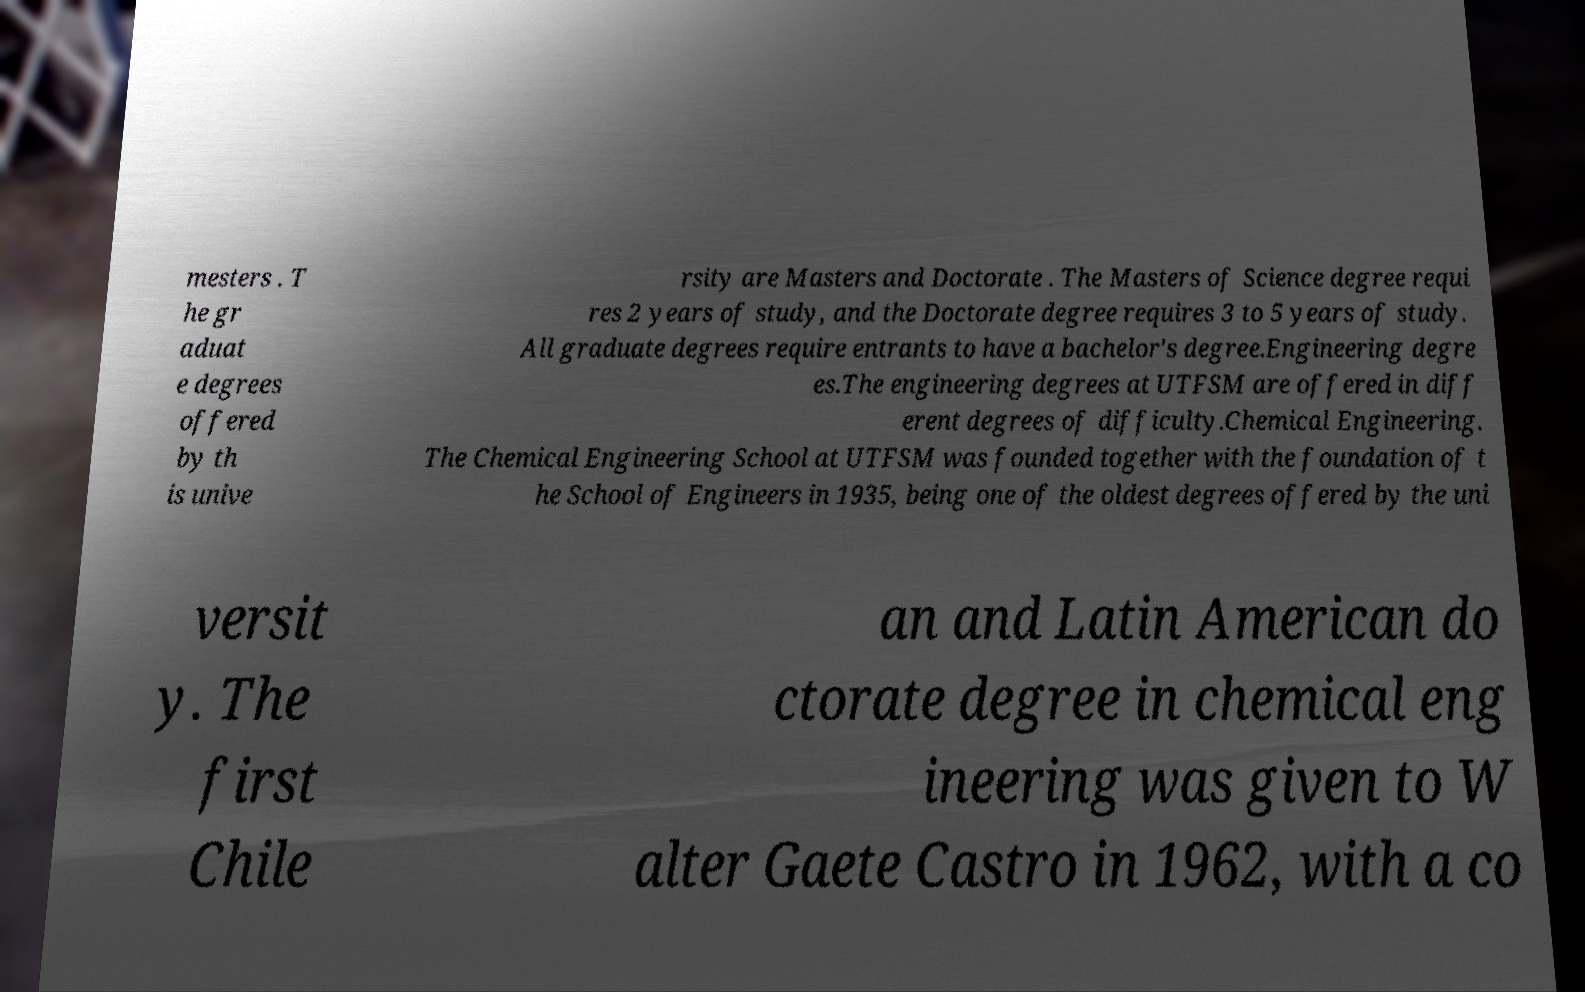Could you extract and type out the text from this image? mesters . T he gr aduat e degrees offered by th is unive rsity are Masters and Doctorate . The Masters of Science degree requi res 2 years of study, and the Doctorate degree requires 3 to 5 years of study. All graduate degrees require entrants to have a bachelor's degree.Engineering degre es.The engineering degrees at UTFSM are offered in diff erent degrees of difficulty.Chemical Engineering. The Chemical Engineering School at UTFSM was founded together with the foundation of t he School of Engineers in 1935, being one of the oldest degrees offered by the uni versit y. The first Chile an and Latin American do ctorate degree in chemical eng ineering was given to W alter Gaete Castro in 1962, with a co 